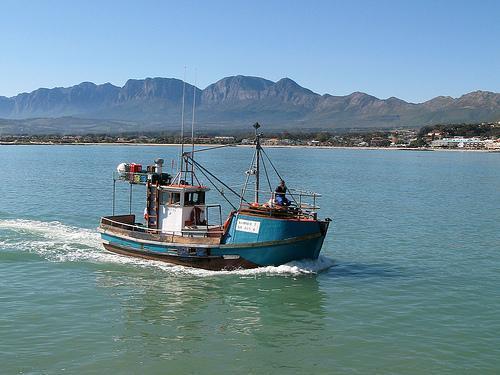How many boats are there?
Give a very brief answer. 1. How many boats are on the water?
Give a very brief answer. 1. How many people are on the boat?
Give a very brief answer. 1. How many boats are shown?
Give a very brief answer. 1. How many clouds are there?
Give a very brief answer. 0. How many people are visible?
Give a very brief answer. 1. How many antennas does the boat have?
Give a very brief answer. 2. 